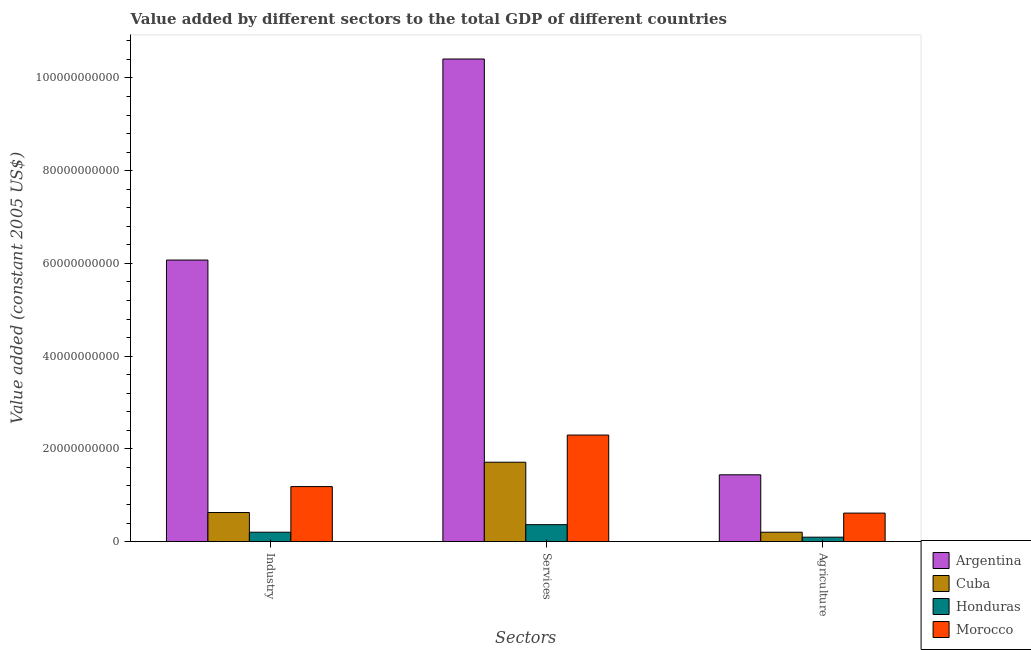Are the number of bars per tick equal to the number of legend labels?
Provide a short and direct response. Yes. Are the number of bars on each tick of the X-axis equal?
Provide a succinct answer. Yes. How many bars are there on the 1st tick from the left?
Your response must be concise. 4. How many bars are there on the 3rd tick from the right?
Keep it short and to the point. 4. What is the label of the 1st group of bars from the left?
Give a very brief answer. Industry. What is the value added by services in Cuba?
Provide a succinct answer. 1.71e+1. Across all countries, what is the maximum value added by services?
Ensure brevity in your answer.  1.04e+11. Across all countries, what is the minimum value added by agricultural sector?
Your answer should be very brief. 9.44e+08. In which country was the value added by agricultural sector minimum?
Provide a short and direct response. Honduras. What is the total value added by services in the graph?
Your answer should be very brief. 1.48e+11. What is the difference between the value added by services in Argentina and that in Cuba?
Provide a short and direct response. 8.70e+1. What is the difference between the value added by services in Morocco and the value added by industrial sector in Argentina?
Give a very brief answer. -3.77e+1. What is the average value added by services per country?
Give a very brief answer. 3.70e+1. What is the difference between the value added by services and value added by industrial sector in Argentina?
Keep it short and to the point. 4.34e+1. What is the ratio of the value added by services in Argentina to that in Morocco?
Your response must be concise. 4.53. What is the difference between the highest and the second highest value added by services?
Keep it short and to the point. 8.11e+1. What is the difference between the highest and the lowest value added by services?
Ensure brevity in your answer.  1.00e+11. In how many countries, is the value added by industrial sector greater than the average value added by industrial sector taken over all countries?
Your answer should be compact. 1. Is the sum of the value added by services in Argentina and Honduras greater than the maximum value added by industrial sector across all countries?
Offer a terse response. Yes. What does the 2nd bar from the left in Services represents?
Provide a succinct answer. Cuba. What does the 3rd bar from the right in Services represents?
Offer a very short reply. Cuba. Is it the case that in every country, the sum of the value added by industrial sector and value added by services is greater than the value added by agricultural sector?
Make the answer very short. Yes. How many bars are there?
Your answer should be very brief. 12. Are all the bars in the graph horizontal?
Give a very brief answer. No. What is the difference between two consecutive major ticks on the Y-axis?
Your response must be concise. 2.00e+1. Does the graph contain grids?
Your answer should be compact. No. Where does the legend appear in the graph?
Your answer should be compact. Bottom right. What is the title of the graph?
Your answer should be very brief. Value added by different sectors to the total GDP of different countries. What is the label or title of the X-axis?
Provide a succinct answer. Sectors. What is the label or title of the Y-axis?
Give a very brief answer. Value added (constant 2005 US$). What is the Value added (constant 2005 US$) of Argentina in Industry?
Give a very brief answer. 6.07e+1. What is the Value added (constant 2005 US$) in Cuba in Industry?
Provide a succinct answer. 6.26e+09. What is the Value added (constant 2005 US$) in Honduras in Industry?
Provide a short and direct response. 2.02e+09. What is the Value added (constant 2005 US$) of Morocco in Industry?
Give a very brief answer. 1.19e+1. What is the Value added (constant 2005 US$) in Argentina in Services?
Provide a short and direct response. 1.04e+11. What is the Value added (constant 2005 US$) of Cuba in Services?
Offer a very short reply. 1.71e+1. What is the Value added (constant 2005 US$) in Honduras in Services?
Your response must be concise. 3.64e+09. What is the Value added (constant 2005 US$) in Morocco in Services?
Provide a short and direct response. 2.30e+1. What is the Value added (constant 2005 US$) of Argentina in Agriculture?
Make the answer very short. 1.44e+1. What is the Value added (constant 2005 US$) of Cuba in Agriculture?
Ensure brevity in your answer.  2.01e+09. What is the Value added (constant 2005 US$) of Honduras in Agriculture?
Offer a very short reply. 9.44e+08. What is the Value added (constant 2005 US$) of Morocco in Agriculture?
Your response must be concise. 6.14e+09. Across all Sectors, what is the maximum Value added (constant 2005 US$) of Argentina?
Keep it short and to the point. 1.04e+11. Across all Sectors, what is the maximum Value added (constant 2005 US$) in Cuba?
Give a very brief answer. 1.71e+1. Across all Sectors, what is the maximum Value added (constant 2005 US$) in Honduras?
Provide a short and direct response. 3.64e+09. Across all Sectors, what is the maximum Value added (constant 2005 US$) of Morocco?
Your answer should be compact. 2.30e+1. Across all Sectors, what is the minimum Value added (constant 2005 US$) of Argentina?
Ensure brevity in your answer.  1.44e+1. Across all Sectors, what is the minimum Value added (constant 2005 US$) in Cuba?
Make the answer very short. 2.01e+09. Across all Sectors, what is the minimum Value added (constant 2005 US$) of Honduras?
Ensure brevity in your answer.  9.44e+08. Across all Sectors, what is the minimum Value added (constant 2005 US$) of Morocco?
Provide a short and direct response. 6.14e+09. What is the total Value added (constant 2005 US$) of Argentina in the graph?
Ensure brevity in your answer.  1.79e+11. What is the total Value added (constant 2005 US$) of Cuba in the graph?
Provide a succinct answer. 2.54e+1. What is the total Value added (constant 2005 US$) of Honduras in the graph?
Give a very brief answer. 6.60e+09. What is the total Value added (constant 2005 US$) of Morocco in the graph?
Keep it short and to the point. 4.10e+1. What is the difference between the Value added (constant 2005 US$) in Argentina in Industry and that in Services?
Your answer should be very brief. -4.34e+1. What is the difference between the Value added (constant 2005 US$) of Cuba in Industry and that in Services?
Offer a very short reply. -1.08e+1. What is the difference between the Value added (constant 2005 US$) of Honduras in Industry and that in Services?
Your answer should be compact. -1.63e+09. What is the difference between the Value added (constant 2005 US$) in Morocco in Industry and that in Services?
Provide a short and direct response. -1.11e+1. What is the difference between the Value added (constant 2005 US$) in Argentina in Industry and that in Agriculture?
Your answer should be very brief. 4.63e+1. What is the difference between the Value added (constant 2005 US$) in Cuba in Industry and that in Agriculture?
Offer a very short reply. 4.25e+09. What is the difference between the Value added (constant 2005 US$) in Honduras in Industry and that in Agriculture?
Your answer should be very brief. 1.07e+09. What is the difference between the Value added (constant 2005 US$) in Morocco in Industry and that in Agriculture?
Ensure brevity in your answer.  5.72e+09. What is the difference between the Value added (constant 2005 US$) in Argentina in Services and that in Agriculture?
Give a very brief answer. 8.97e+1. What is the difference between the Value added (constant 2005 US$) of Cuba in Services and that in Agriculture?
Provide a short and direct response. 1.51e+1. What is the difference between the Value added (constant 2005 US$) of Honduras in Services and that in Agriculture?
Give a very brief answer. 2.70e+09. What is the difference between the Value added (constant 2005 US$) in Morocco in Services and that in Agriculture?
Your answer should be compact. 1.68e+1. What is the difference between the Value added (constant 2005 US$) in Argentina in Industry and the Value added (constant 2005 US$) in Cuba in Services?
Your answer should be compact. 4.36e+1. What is the difference between the Value added (constant 2005 US$) of Argentina in Industry and the Value added (constant 2005 US$) of Honduras in Services?
Make the answer very short. 5.71e+1. What is the difference between the Value added (constant 2005 US$) of Argentina in Industry and the Value added (constant 2005 US$) of Morocco in Services?
Provide a short and direct response. 3.77e+1. What is the difference between the Value added (constant 2005 US$) in Cuba in Industry and the Value added (constant 2005 US$) in Honduras in Services?
Your response must be concise. 2.62e+09. What is the difference between the Value added (constant 2005 US$) of Cuba in Industry and the Value added (constant 2005 US$) of Morocco in Services?
Provide a short and direct response. -1.67e+1. What is the difference between the Value added (constant 2005 US$) in Honduras in Industry and the Value added (constant 2005 US$) in Morocco in Services?
Give a very brief answer. -2.10e+1. What is the difference between the Value added (constant 2005 US$) of Argentina in Industry and the Value added (constant 2005 US$) of Cuba in Agriculture?
Ensure brevity in your answer.  5.87e+1. What is the difference between the Value added (constant 2005 US$) in Argentina in Industry and the Value added (constant 2005 US$) in Honduras in Agriculture?
Provide a succinct answer. 5.98e+1. What is the difference between the Value added (constant 2005 US$) of Argentina in Industry and the Value added (constant 2005 US$) of Morocco in Agriculture?
Ensure brevity in your answer.  5.46e+1. What is the difference between the Value added (constant 2005 US$) of Cuba in Industry and the Value added (constant 2005 US$) of Honduras in Agriculture?
Offer a terse response. 5.32e+09. What is the difference between the Value added (constant 2005 US$) of Cuba in Industry and the Value added (constant 2005 US$) of Morocco in Agriculture?
Keep it short and to the point. 1.26e+08. What is the difference between the Value added (constant 2005 US$) in Honduras in Industry and the Value added (constant 2005 US$) in Morocco in Agriculture?
Give a very brief answer. -4.12e+09. What is the difference between the Value added (constant 2005 US$) in Argentina in Services and the Value added (constant 2005 US$) in Cuba in Agriculture?
Keep it short and to the point. 1.02e+11. What is the difference between the Value added (constant 2005 US$) in Argentina in Services and the Value added (constant 2005 US$) in Honduras in Agriculture?
Provide a succinct answer. 1.03e+11. What is the difference between the Value added (constant 2005 US$) in Argentina in Services and the Value added (constant 2005 US$) in Morocco in Agriculture?
Make the answer very short. 9.79e+1. What is the difference between the Value added (constant 2005 US$) in Cuba in Services and the Value added (constant 2005 US$) in Honduras in Agriculture?
Keep it short and to the point. 1.62e+1. What is the difference between the Value added (constant 2005 US$) in Cuba in Services and the Value added (constant 2005 US$) in Morocco in Agriculture?
Give a very brief answer. 1.10e+1. What is the difference between the Value added (constant 2005 US$) of Honduras in Services and the Value added (constant 2005 US$) of Morocco in Agriculture?
Give a very brief answer. -2.49e+09. What is the average Value added (constant 2005 US$) in Argentina per Sectors?
Your response must be concise. 5.97e+1. What is the average Value added (constant 2005 US$) in Cuba per Sectors?
Provide a short and direct response. 8.46e+09. What is the average Value added (constant 2005 US$) of Honduras per Sectors?
Give a very brief answer. 2.20e+09. What is the average Value added (constant 2005 US$) in Morocco per Sectors?
Keep it short and to the point. 1.37e+1. What is the difference between the Value added (constant 2005 US$) in Argentina and Value added (constant 2005 US$) in Cuba in Industry?
Keep it short and to the point. 5.45e+1. What is the difference between the Value added (constant 2005 US$) in Argentina and Value added (constant 2005 US$) in Honduras in Industry?
Your response must be concise. 5.87e+1. What is the difference between the Value added (constant 2005 US$) of Argentina and Value added (constant 2005 US$) of Morocco in Industry?
Your answer should be compact. 4.89e+1. What is the difference between the Value added (constant 2005 US$) of Cuba and Value added (constant 2005 US$) of Honduras in Industry?
Offer a very short reply. 4.25e+09. What is the difference between the Value added (constant 2005 US$) of Cuba and Value added (constant 2005 US$) of Morocco in Industry?
Offer a very short reply. -5.59e+09. What is the difference between the Value added (constant 2005 US$) in Honduras and Value added (constant 2005 US$) in Morocco in Industry?
Make the answer very short. -9.84e+09. What is the difference between the Value added (constant 2005 US$) of Argentina and Value added (constant 2005 US$) of Cuba in Services?
Provide a short and direct response. 8.70e+1. What is the difference between the Value added (constant 2005 US$) in Argentina and Value added (constant 2005 US$) in Honduras in Services?
Ensure brevity in your answer.  1.00e+11. What is the difference between the Value added (constant 2005 US$) of Argentina and Value added (constant 2005 US$) of Morocco in Services?
Provide a succinct answer. 8.11e+1. What is the difference between the Value added (constant 2005 US$) in Cuba and Value added (constant 2005 US$) in Honduras in Services?
Give a very brief answer. 1.35e+1. What is the difference between the Value added (constant 2005 US$) in Cuba and Value added (constant 2005 US$) in Morocco in Services?
Make the answer very short. -5.86e+09. What is the difference between the Value added (constant 2005 US$) of Honduras and Value added (constant 2005 US$) of Morocco in Services?
Give a very brief answer. -1.93e+1. What is the difference between the Value added (constant 2005 US$) of Argentina and Value added (constant 2005 US$) of Cuba in Agriculture?
Offer a very short reply. 1.24e+1. What is the difference between the Value added (constant 2005 US$) in Argentina and Value added (constant 2005 US$) in Honduras in Agriculture?
Your response must be concise. 1.35e+1. What is the difference between the Value added (constant 2005 US$) of Argentina and Value added (constant 2005 US$) of Morocco in Agriculture?
Provide a short and direct response. 8.26e+09. What is the difference between the Value added (constant 2005 US$) in Cuba and Value added (constant 2005 US$) in Honduras in Agriculture?
Ensure brevity in your answer.  1.07e+09. What is the difference between the Value added (constant 2005 US$) in Cuba and Value added (constant 2005 US$) in Morocco in Agriculture?
Give a very brief answer. -4.12e+09. What is the difference between the Value added (constant 2005 US$) in Honduras and Value added (constant 2005 US$) in Morocco in Agriculture?
Your answer should be very brief. -5.19e+09. What is the ratio of the Value added (constant 2005 US$) in Argentina in Industry to that in Services?
Your answer should be very brief. 0.58. What is the ratio of the Value added (constant 2005 US$) in Cuba in Industry to that in Services?
Offer a very short reply. 0.37. What is the ratio of the Value added (constant 2005 US$) of Honduras in Industry to that in Services?
Offer a very short reply. 0.55. What is the ratio of the Value added (constant 2005 US$) in Morocco in Industry to that in Services?
Provide a succinct answer. 0.52. What is the ratio of the Value added (constant 2005 US$) of Argentina in Industry to that in Agriculture?
Offer a terse response. 4.22. What is the ratio of the Value added (constant 2005 US$) of Cuba in Industry to that in Agriculture?
Your answer should be very brief. 3.11. What is the ratio of the Value added (constant 2005 US$) in Honduras in Industry to that in Agriculture?
Provide a succinct answer. 2.14. What is the ratio of the Value added (constant 2005 US$) of Morocco in Industry to that in Agriculture?
Your response must be concise. 1.93. What is the ratio of the Value added (constant 2005 US$) in Argentina in Services to that in Agriculture?
Offer a terse response. 7.23. What is the ratio of the Value added (constant 2005 US$) in Cuba in Services to that in Agriculture?
Offer a terse response. 8.49. What is the ratio of the Value added (constant 2005 US$) of Honduras in Services to that in Agriculture?
Offer a terse response. 3.86. What is the ratio of the Value added (constant 2005 US$) in Morocco in Services to that in Agriculture?
Give a very brief answer. 3.74. What is the difference between the highest and the second highest Value added (constant 2005 US$) of Argentina?
Ensure brevity in your answer.  4.34e+1. What is the difference between the highest and the second highest Value added (constant 2005 US$) in Cuba?
Provide a short and direct response. 1.08e+1. What is the difference between the highest and the second highest Value added (constant 2005 US$) in Honduras?
Make the answer very short. 1.63e+09. What is the difference between the highest and the second highest Value added (constant 2005 US$) in Morocco?
Ensure brevity in your answer.  1.11e+1. What is the difference between the highest and the lowest Value added (constant 2005 US$) in Argentina?
Your answer should be compact. 8.97e+1. What is the difference between the highest and the lowest Value added (constant 2005 US$) of Cuba?
Provide a short and direct response. 1.51e+1. What is the difference between the highest and the lowest Value added (constant 2005 US$) of Honduras?
Your answer should be compact. 2.70e+09. What is the difference between the highest and the lowest Value added (constant 2005 US$) in Morocco?
Keep it short and to the point. 1.68e+1. 